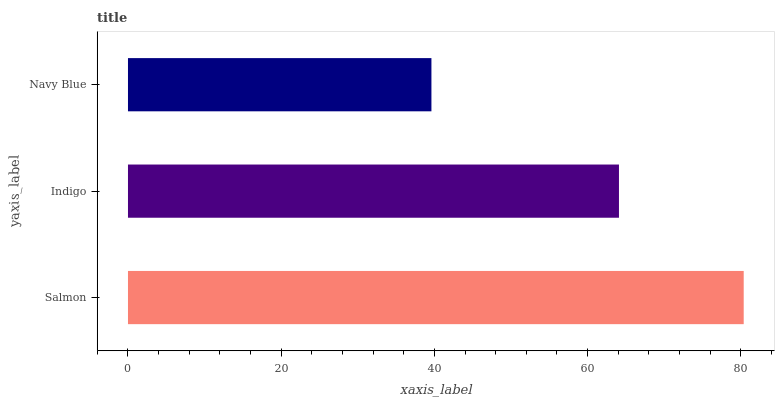Is Navy Blue the minimum?
Answer yes or no. Yes. Is Salmon the maximum?
Answer yes or no. Yes. Is Indigo the minimum?
Answer yes or no. No. Is Indigo the maximum?
Answer yes or no. No. Is Salmon greater than Indigo?
Answer yes or no. Yes. Is Indigo less than Salmon?
Answer yes or no. Yes. Is Indigo greater than Salmon?
Answer yes or no. No. Is Salmon less than Indigo?
Answer yes or no. No. Is Indigo the high median?
Answer yes or no. Yes. Is Indigo the low median?
Answer yes or no. Yes. Is Salmon the high median?
Answer yes or no. No. Is Navy Blue the low median?
Answer yes or no. No. 